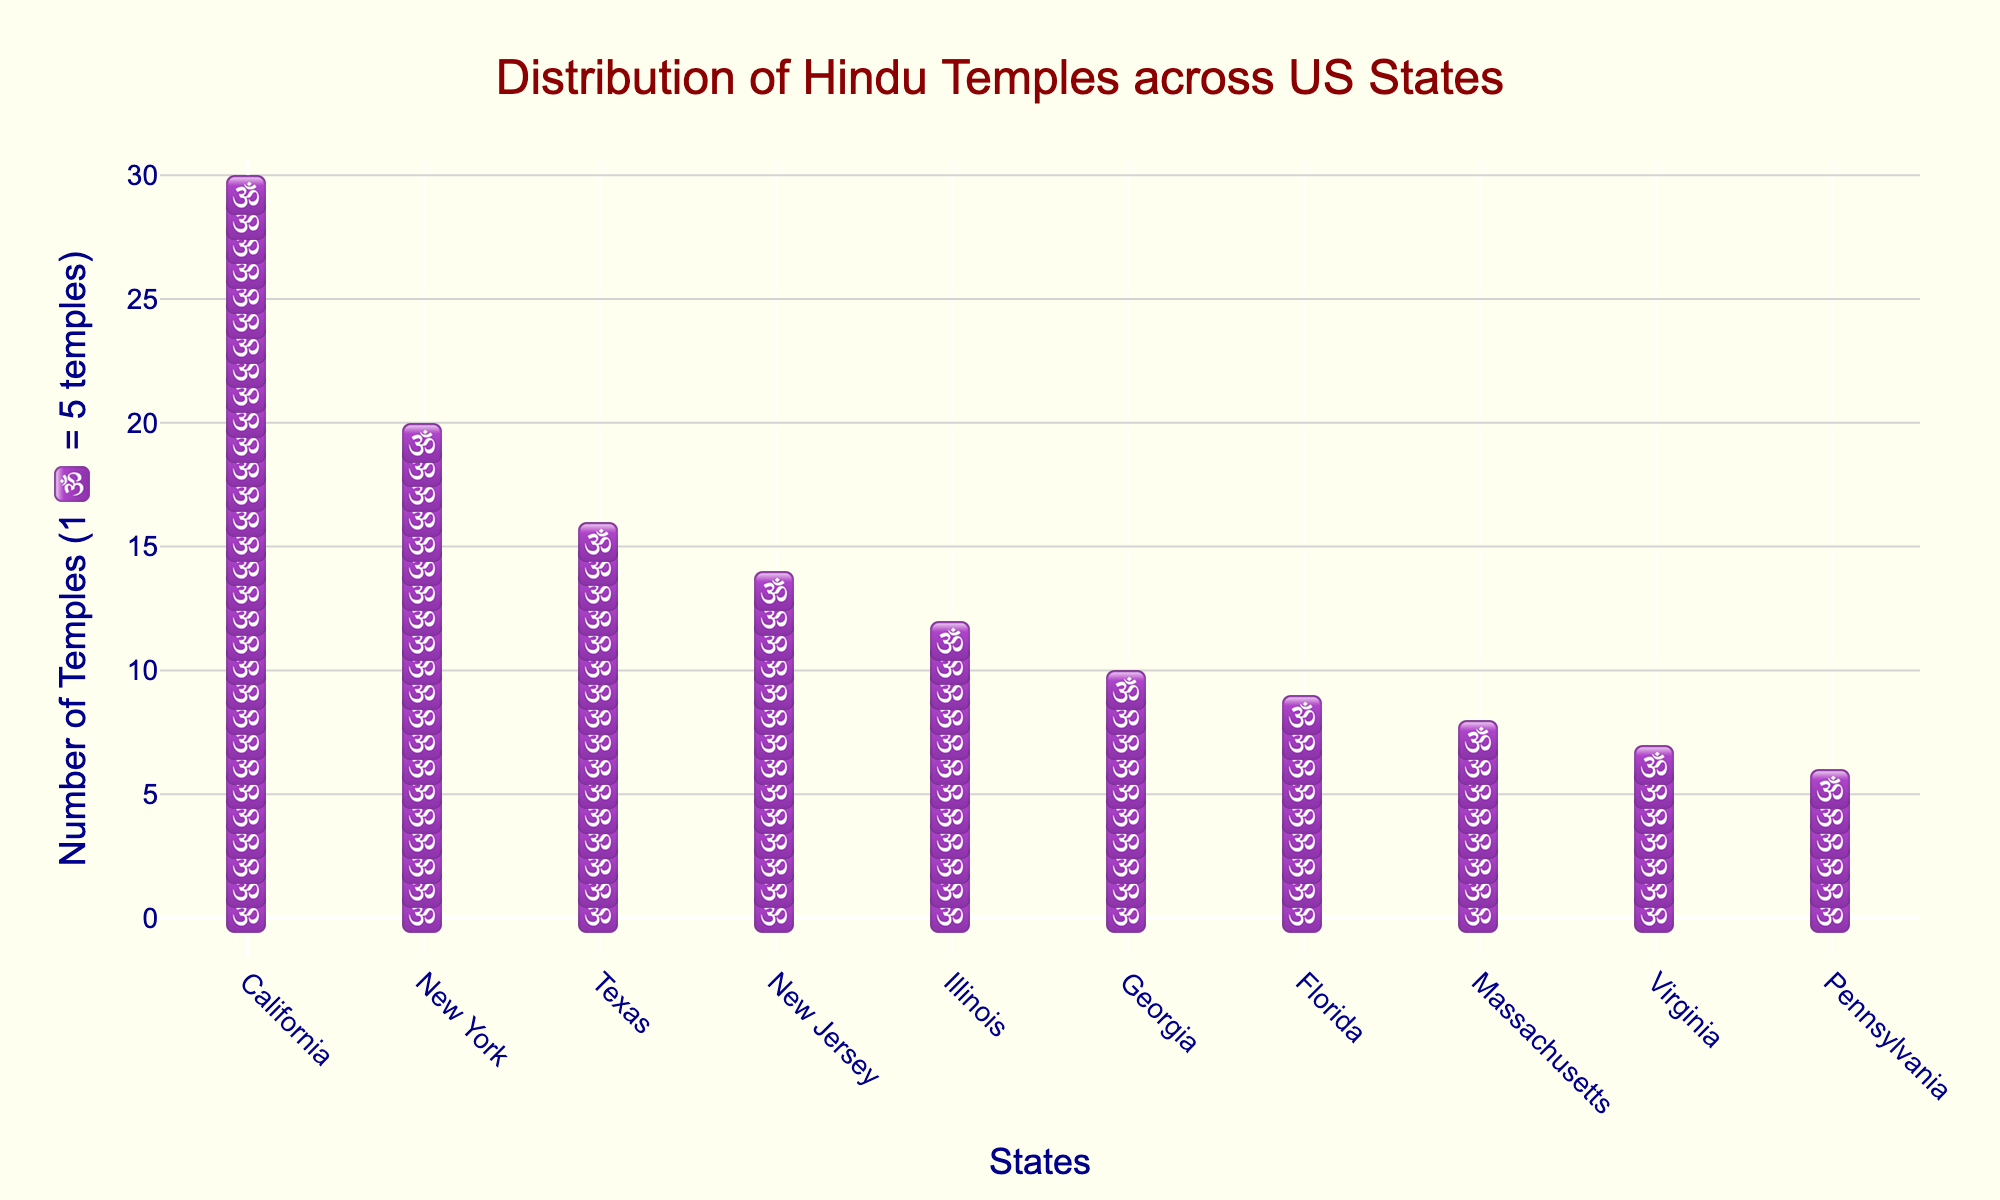How many states have more than 50 Hindu temples? Check each state and count those with more than 50 temples: California (150), New York (100), Texas (80), New Jersey (70), Illinois (60), Georgia (50)
Answer: 5 Which state has the highest number of Hindu temples? The state with the most icons (🕉️) represents the highest number of temples. California leads with the most symbols.
Answer: California Which states have fewer Hindu temples than Texas? States with fewer icons than Texas (80 temples) are New Jersey, Illinois, Georgia, Florida, Massachusetts, Virginia, and Pennsylvania.
Answer: New Jersey, Illinois, Georgia, Florida, Massachusetts, Virginia, Pennsylvania How many total icons (🕉️) are displayed in the plot? Tally the icons for each state: California (30), New York (20), Texas (16), New Jersey (14), Illinois (12), Georgia (10), Florida (9), Massachusetts (8), Virginia (7), Pennsylvania (6). Sum: 30+20+16+14+12+10+9+8+7+6 = 132.
Answer: 132 Compare the number of Hindu temples in New York to Florida. New York has 100 temples, while Florida has 45. New York has more icons compared to Florida.
Answer: New York has more How many more Hindu temples does California have compared to Pennsylvania? California has 150 temples and Pennsylvania has 30. Difference: 150 - 30 = 120 temples.
Answer: 120 temples Which state has the median number of Hindu temples? List the states in order: Pennsylvania (30), Virginia (35), Massachusetts (40), Florida (45), Georgia (50), Illinois (60), New Jersey (70), Texas (80), New York (100), California (150). Median position: 5th and 6th states (average): (Georgia (50) + Illinois (60))/2 = 55 temples.
Answer: Between Georgia and Illinois How does the number of temples in New Jersey compare to Illinois? New Jersey with 70 and Illinois with 60; New Jersey has more.
Answer: New Jersey has more What is the average number of Hindu temples across the listed states? Sum the total number of temples: 150 (CA) + 100 (NY) + 80 (TX) + 70 (NJ) + 60 (IL) + 50 (GA) + 45 (FL) + 40 (MA) + 35 (VA) + 30 (PA) = 660. Average: 660/10 = 66.
Answer: 66 temples 